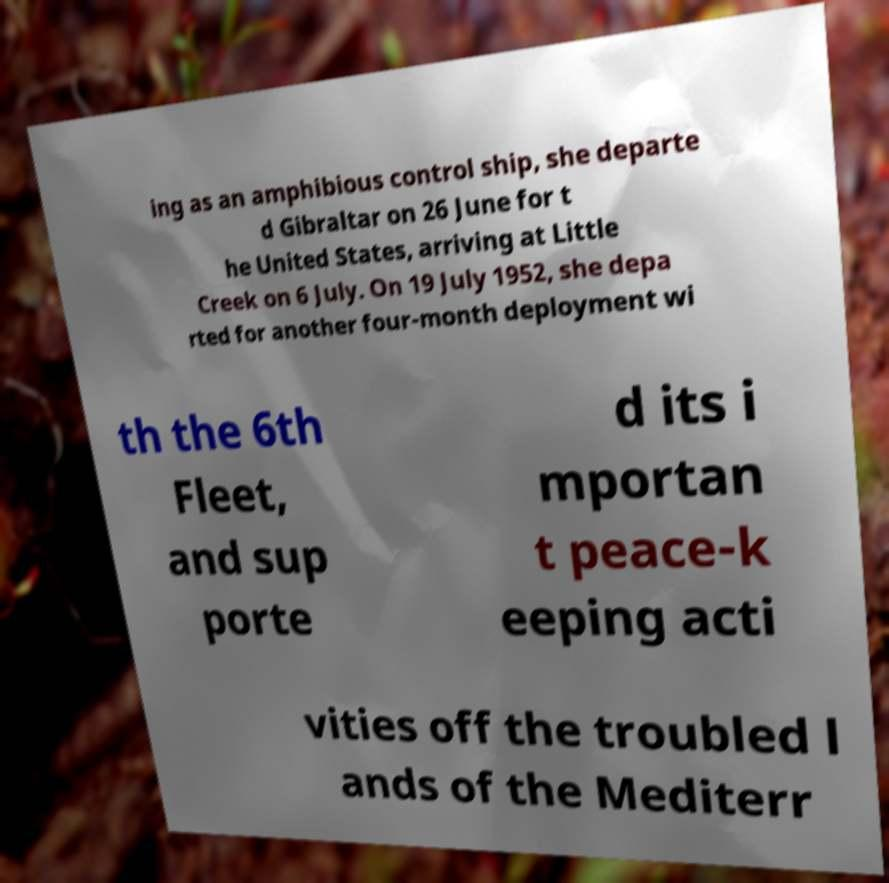Could you extract and type out the text from this image? ing as an amphibious control ship, she departe d Gibraltar on 26 June for t he United States, arriving at Little Creek on 6 July. On 19 July 1952, she depa rted for another four-month deployment wi th the 6th Fleet, and sup porte d its i mportan t peace-k eeping acti vities off the troubled l ands of the Mediterr 